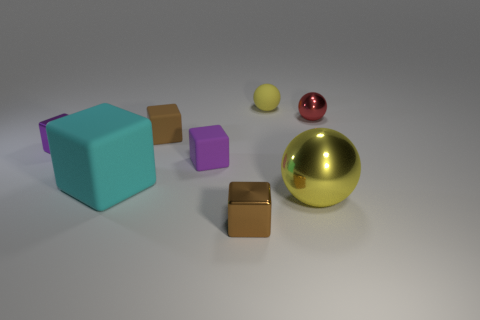Are there an equal number of big blocks behind the brown rubber cube and small brown cubes?
Your answer should be compact. No. Do the cyan cube and the brown metallic object have the same size?
Provide a short and direct response. No. There is a cube that is right of the brown rubber thing and behind the yellow shiny thing; what is its material?
Make the answer very short. Rubber. How many yellow metallic things have the same shape as the tiny red metallic thing?
Your answer should be very brief. 1. What is the material of the ball that is in front of the big cyan object?
Keep it short and to the point. Metal. Are there fewer cyan rubber cubes that are behind the red metal thing than yellow rubber spheres?
Your answer should be very brief. Yes. Do the yellow metal thing and the small purple shiny object have the same shape?
Offer a terse response. No. Is there anything else that is the same shape as the small purple matte object?
Keep it short and to the point. Yes. Are any green metallic cylinders visible?
Your answer should be compact. No. There is a red metal thing; does it have the same shape as the large object that is to the left of the tiny yellow rubber object?
Make the answer very short. No. 